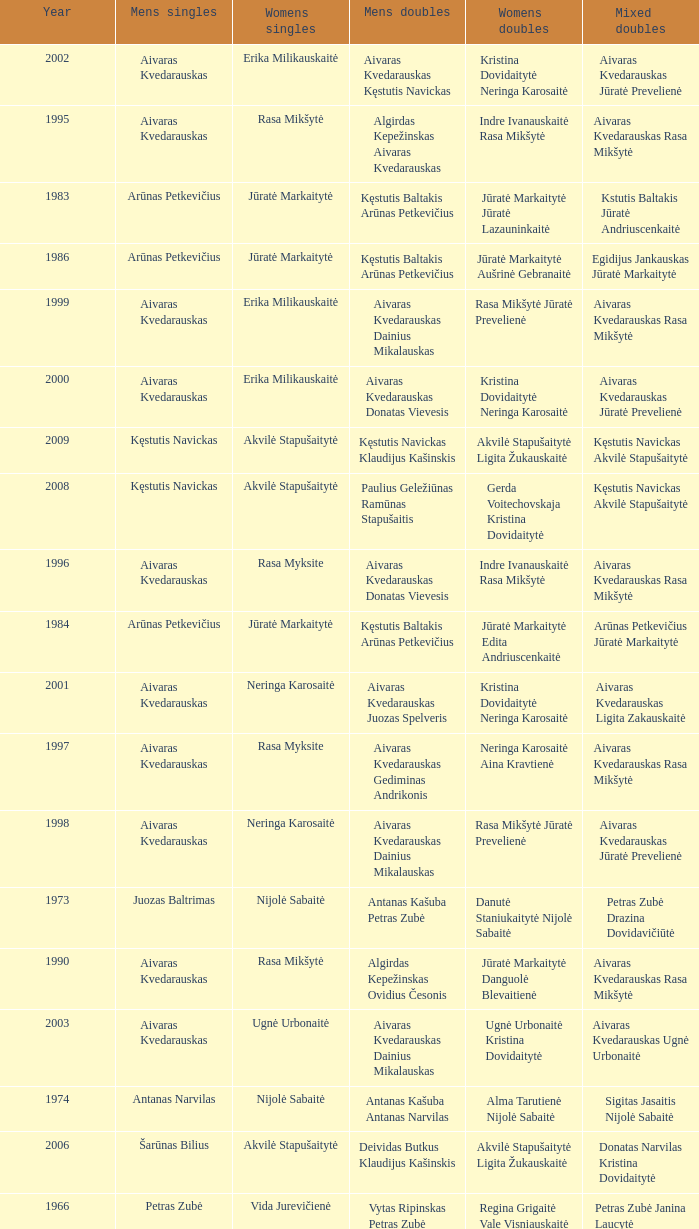What was the first year of the Lithuanian National Badminton Championships? 1963.0. Can you give me this table as a dict? {'header': ['Year', 'Mens singles', 'Womens singles', 'Mens doubles', 'Womens doubles', 'Mixed doubles'], 'rows': [['2002', 'Aivaras Kvedarauskas', 'Erika Milikauskaitė', 'Aivaras Kvedarauskas Kęstutis Navickas', 'Kristina Dovidaitytė Neringa Karosaitė', 'Aivaras Kvedarauskas Jūratė Prevelienė'], ['1995', 'Aivaras Kvedarauskas', 'Rasa Mikšytė', 'Algirdas Kepežinskas Aivaras Kvedarauskas', 'Indre Ivanauskaitė Rasa Mikšytė', 'Aivaras Kvedarauskas Rasa Mikšytė'], ['1983', 'Arūnas Petkevičius', 'Jūratė Markaitytė', 'Kęstutis Baltakis Arūnas Petkevičius', 'Jūratė Markaitytė Jūratė Lazauninkaitė', 'Kstutis Baltakis Jūratė Andriuscenkaitė'], ['1986', 'Arūnas Petkevičius', 'Jūratė Markaitytė', 'Kęstutis Baltakis Arūnas Petkevičius', 'Jūratė Markaitytė Aušrinė Gebranaitė', 'Egidijus Jankauskas Jūratė Markaitytė'], ['1999', 'Aivaras Kvedarauskas', 'Erika Milikauskaitė', 'Aivaras Kvedarauskas Dainius Mikalauskas', 'Rasa Mikšytė Jūratė Prevelienė', 'Aivaras Kvedarauskas Rasa Mikšytė'], ['2000', 'Aivaras Kvedarauskas', 'Erika Milikauskaitė', 'Aivaras Kvedarauskas Donatas Vievesis', 'Kristina Dovidaitytė Neringa Karosaitė', 'Aivaras Kvedarauskas Jūratė Prevelienė'], ['2009', 'Kęstutis Navickas', 'Akvilė Stapušaitytė', 'Kęstutis Navickas Klaudijus Kašinskis', 'Akvilė Stapušaitytė Ligita Žukauskaitė', 'Kęstutis Navickas Akvilė Stapušaitytė'], ['2008', 'Kęstutis Navickas', 'Akvilė Stapušaitytė', 'Paulius Geležiūnas Ramūnas Stapušaitis', 'Gerda Voitechovskaja Kristina Dovidaitytė', 'Kęstutis Navickas Akvilė Stapušaitytė'], ['1996', 'Aivaras Kvedarauskas', 'Rasa Myksite', 'Aivaras Kvedarauskas Donatas Vievesis', 'Indre Ivanauskaitė Rasa Mikšytė', 'Aivaras Kvedarauskas Rasa Mikšytė'], ['1984', 'Arūnas Petkevičius', 'Jūratė Markaitytė', 'Kęstutis Baltakis Arūnas Petkevičius', 'Jūratė Markaitytė Edita Andriuscenkaitė', 'Arūnas Petkevičius Jūratė Markaitytė'], ['2001', 'Aivaras Kvedarauskas', 'Neringa Karosaitė', 'Aivaras Kvedarauskas Juozas Spelveris', 'Kristina Dovidaitytė Neringa Karosaitė', 'Aivaras Kvedarauskas Ligita Zakauskaitė'], ['1997', 'Aivaras Kvedarauskas', 'Rasa Myksite', 'Aivaras Kvedarauskas Gediminas Andrikonis', 'Neringa Karosaitė Aina Kravtienė', 'Aivaras Kvedarauskas Rasa Mikšytė'], ['1998', 'Aivaras Kvedarauskas', 'Neringa Karosaitė', 'Aivaras Kvedarauskas Dainius Mikalauskas', 'Rasa Mikšytė Jūratė Prevelienė', 'Aivaras Kvedarauskas Jūratė Prevelienė'], ['1973', 'Juozas Baltrimas', 'Nijolė Sabaitė', 'Antanas Kašuba Petras Zubė', 'Danutė Staniukaitytė Nijolė Sabaitė', 'Petras Zubė Drazina Dovidavičiūtė'], ['1990', 'Aivaras Kvedarauskas', 'Rasa Mikšytė', 'Algirdas Kepežinskas Ovidius Česonis', 'Jūratė Markaitytė Danguolė Blevaitienė', 'Aivaras Kvedarauskas Rasa Mikšytė'], ['2003', 'Aivaras Kvedarauskas', 'Ugnė Urbonaitė', 'Aivaras Kvedarauskas Dainius Mikalauskas', 'Ugnė Urbonaitė Kristina Dovidaitytė', 'Aivaras Kvedarauskas Ugnė Urbonaitė'], ['1974', 'Antanas Narvilas', 'Nijolė Sabaitė', 'Antanas Kašuba Antanas Narvilas', 'Alma Tarutienė Nijolė Sabaitė', 'Sigitas Jasaitis Nijolė Sabaitė'], ['2006', 'Šarūnas Bilius', 'Akvilė Stapušaitytė', 'Deividas Butkus Klaudijus Kašinskis', 'Akvilė Stapušaitytė Ligita Žukauskaitė', 'Donatas Narvilas Kristina Dovidaitytė'], ['1966', 'Petras Zubė', 'Vida Jurevičienė', 'Vytas Ripinskas Petras Zubė', 'Regina Grigaitė Vale Visniauskaitė', 'Petras Zubė Janina Laucytė'], ['1975', 'Juozas Baltrimas', 'Nijolė Sabaitė', 'Antanas Narvilas Justinas Stankus', 'Genutė Baltrimaitė Danutė Staniukaitytė', 'Juozas Baltrimas Genutė Baltrimaitė'], ['1971', 'Petras Zubė', 'Vida Jurevičienė', 'Antanas Narvilas Petras Zubė', 'Vida Jurevičienė Undinė Jagelaitė', 'Petras Zubė Regina Šemetaitė'], ['1989', 'Ovidijus Cesonis', 'Aušrinė Gabrenaitė', 'Egidijus Jankauskus Ovidius Česonis', 'Aušrinė Gebranaitė Rasa Mikšytė', 'Egidijus Jankauskas Aušrinė Gabrenaitė'], ['1970', 'Giedrius Voroneckas', 'Vida Jurevičienė', 'Regimantas Kijauskas Vidas Kijauskas', 'Vida Jurevičienė Reina Šemetaitė', 'Petras Zubė Regina Šemetaitė'], ['1969', 'Petras Zubė', 'Valė Viskinauskaitė', 'Antanas Narvilas Regimantas Kijauskas', 'Regina Šemetaitė Salvija Petronytė', 'Petras Zubė Regina Minelgienė'], ['1979', 'Antanas Narvilas', 'Virginija Cechanavičiūtė', 'Juozas Baltrimas Kęstutis Dabravolskis', 'Virginija Cechanavičiūtė Milda Taraskevičiūtė', 'Juozas Baltrimas Genutė Baltrimaitė'], ['1978', 'Juozas Baltrimas', 'Virginija Cechanavičiūtė', 'Arturas Jaskevičius Justinas Stankus', 'Virginija Cechanavičiūtė Asta Šimbelytė', 'Rimas Liubartas Virginija Cechanavičiūtė'], ['1977', 'Antanas Narvilas', 'Virginija Cechanavičiūtė', 'Antanas Narvilas Justinas Stankus', 'Virginija Cechanavičiūtė Danutė Staniukaitytė', 'Antanas Narvilas Danguolė Blevaitienė'], ['1963', 'Juozas Kriščiūnas', 'Regina Šemetaitė', 'Juozas Kriščiūnas Povilas Tamošauskas', 'Jolanta Kazarinaitė Aurelija Kostiuškaitė', 'Juozas Kriščiūnas Jolanta Kazarinaitė'], ['1982', 'Juozas Baltrimas', 'Danguolė Blevaitienė', 'Juozas Baltrimas Sigitas Jasaitis', 'Danguolė Blevaitienė Silva Senkutė', 'Anatas Narvilas Danguolė Blevaitienė'], ['1968', 'Juozas Baltrimas', 'Vida Jurevičienė', 'Juozas Kriščiūnas Petras Zubė', 'Vida Jurevičienė Undinė Jagelaitė', 'Juozas Kriščiūnas Vida Jurevičienė'], ['1981', 'Juozas Baltrimas', 'Danguolė Blevaitienė', 'Arturas Jaskevičius Antanas Narvilas', 'Danguolė Blevaitienė Silva Senkutė', 'Anatas Narvilas Danguolė Blevaitienė'], ['2004', 'Kęstutis Navickas', 'Ugnė Urbonaitė', 'Kęstutis Navickas Klaudijus Kasinskis', 'Ugnė Urbonaitė Akvilė Stapušaitytė', 'Kęstutis Navickas Ugnė Urbonaitė'], ['1976', 'Juozas Baltrimas', 'Nijolė Noreikaitė', 'Antanas Narvilas Justinas Stankus', 'Virginija Cechanavičiūtė Nijolė Noreikaitė', 'Juozas Baltrimas Genutė Baltrimaitė'], ['1972', 'Petras Zubė', 'Vida Jurevičienė', 'Juozas Baltrimas Alimantas Mockus', 'Vida Jurevičienė Nijolė Sabaitė', 'Giedrius Voroneckas Vida Jurevičienė'], ['1985', 'Arūnas Petkevičius', 'Jūratė Markaitytė', 'Kęstutis Baltakis Arūnas Petkevičius', 'Jūratė Markaitytė Silva Senkutė', 'Arūnas Petkevičius Jūratė Markaitytė'], ['1988', 'Arūnas Petkevičius', 'Rasa Mikšytė', 'Algirdas Kepežinskas Ovidius Česonis', 'Jūratė Markaitytė Danguolė Blevaitienė', 'Arūnas Petkevičius Danguolė Blevaitienė'], ['1991', 'Egidius Jankauskas', 'Rasa Mikšytė', 'Egidijus Jankauskus Ovidius Česonis', 'Rasa Mikšytė Solveiga Stasaitytė', 'Algirdas Kepežinskas Rasa Mikšytė'], ['1993', 'Edigius Jankauskas', 'Solveiga Stasaitytė', 'Edigius Jankauskas Aivaras Kvedarauskas', 'Rasa Mikšytė Solveiga Stasaitytė', 'Edigius Jankauskas Solveiga Stasaitytė'], ['1967', 'Juozas Baltrimas', 'Vida Jurevičienė', 'Vytas Ripinskas Petras Zubė', 'Vida Jurevičienė Vale Viniauskaitė', 'Petras Zubė Regina Minelgienė'], ['1964', 'Juozas Kriščiūnas', 'Jolanta Kazarinaitė', 'Juozas Kriščiūnas Vladas Rybakovas', 'Jolanta Kazarinaitė Valentina Guseva', 'Vladas Rybakovas Valentina Gusva'], ['1980', 'Arturas Jaskevičius', 'Milda Taraskevičiūtė', 'Juozas Baltrimas Kęstutis Baltakis', 'Asta Šimbelytė Milda Taraskevičiūtė', 'Sigitas Jasaitis Silva Senkutė'], ['2005', 'Kęstutis Navickas', 'Ugnė Urbonaitė', 'Kęstutis Navickas Klaudijus Kasinskis', 'Ugnė Urbonaitė Akvilė Stapušaitytė', 'Donatas Narvilas Kristina Dovidaitytė'], ['1992', 'Egidius Jankauskas', 'Rasa Mikšytė', 'Aivaras Kvedarauskas Vygandas Virzintas', 'Rasa Mikšytė Solveiga Stasaitytė', 'Algirdas Kepežinskas Rasa Mikšytė'], ['2007', 'Kęstutis Navickas', 'Akvilė Stapušaitytė', 'Kęstutis Navickas Klaudijus Kašinskis', 'Gerda Voitechovskaja Kristina Dovidaitytė', 'Kęstutis Navickas Indrė Starevičiūtė'], ['1994', 'Aivaras Kvedarauskas', 'Aina Kravtienė', 'Aivaras Kvedarauskas Ovidijus Zukauskas', 'Indre Ivanauskaitė Rasa Mikšytė', 'Aivaras Kvedarauskas Indze Ivanauskaitė'], ['1965', 'Petras Zubė', 'Regina Šemetaitė', 'Algirdas Vitkauskas Petras Zubė', 'Regina Šemetaitė Janina Laucytė', 'Petras Zubė Regina Vilutytė'], ['1987', 'Egidijus Jankauskas', 'Jūratė Markaitytė', 'Kęstutis Baltakis Arūnas Petkevičius', 'Jūratė Markaitytė Danguolė Blevaitienė', 'Egidijus Jankauskas Danguolė Blevaitienė']]} 